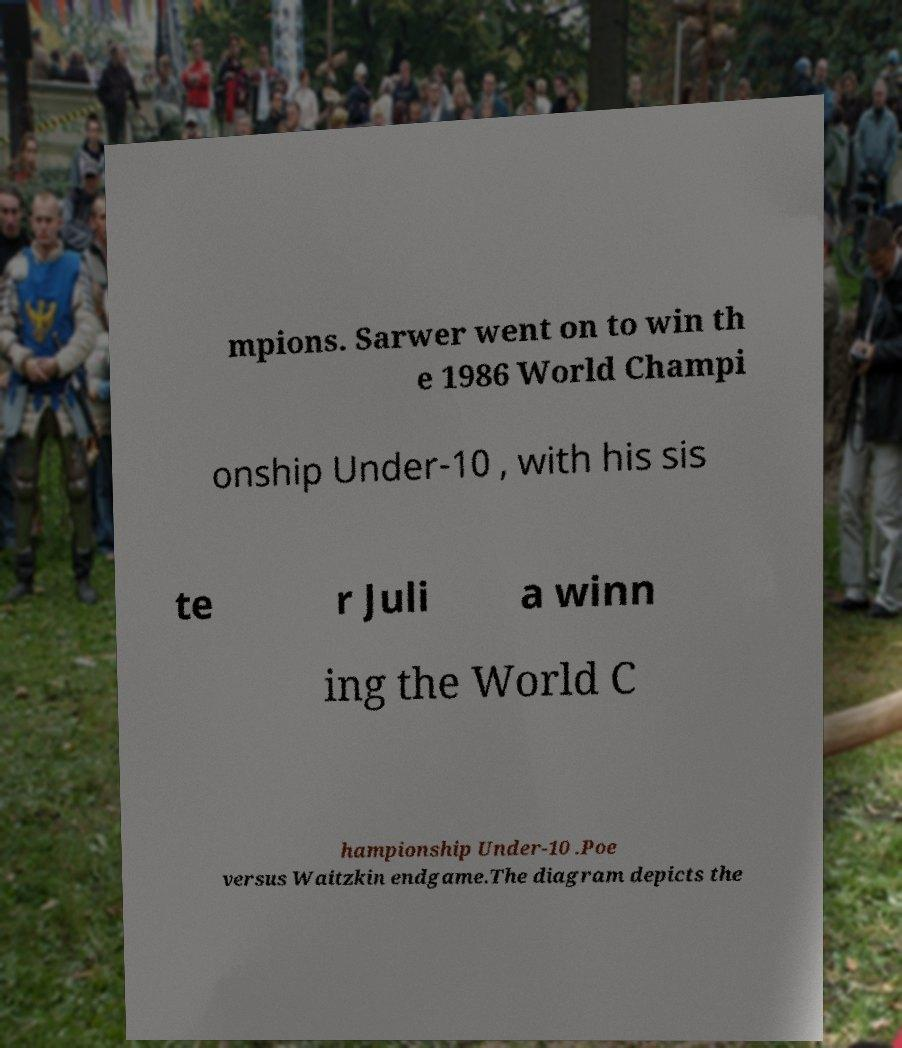I need the written content from this picture converted into text. Can you do that? mpions. Sarwer went on to win th e 1986 World Champi onship Under-10 , with his sis te r Juli a winn ing the World C hampionship Under-10 .Poe versus Waitzkin endgame.The diagram depicts the 